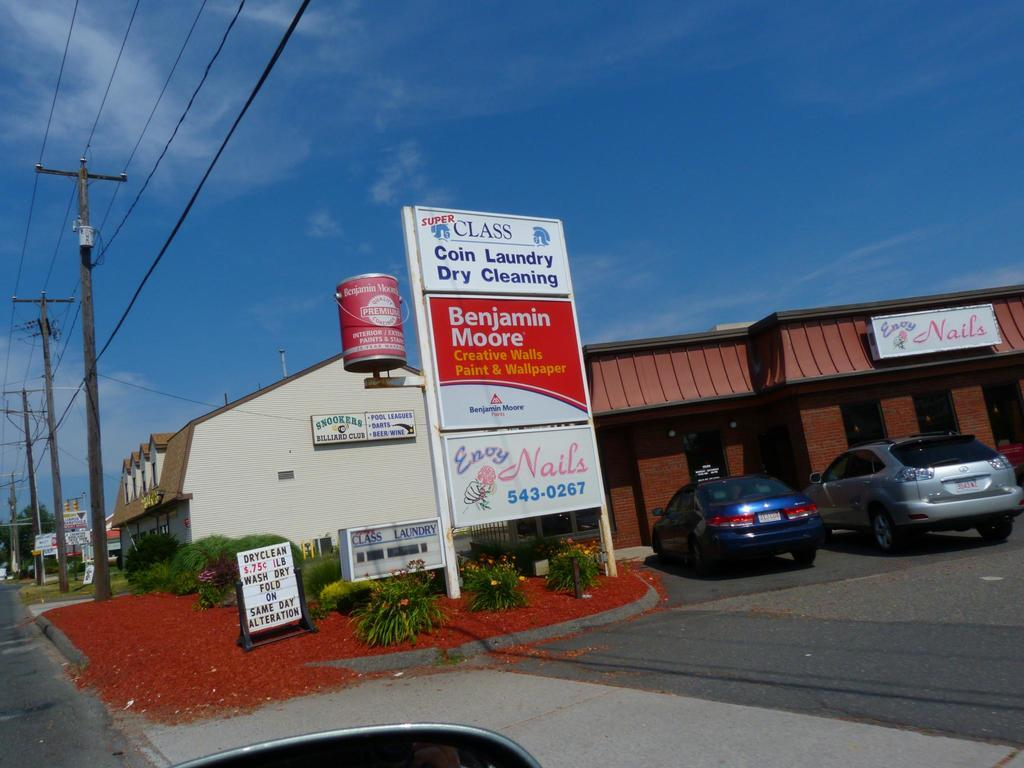<image>
Give a short and clear explanation of the subsequent image. A coin laundry and dry cleaning establishments are advertised on a sign. 